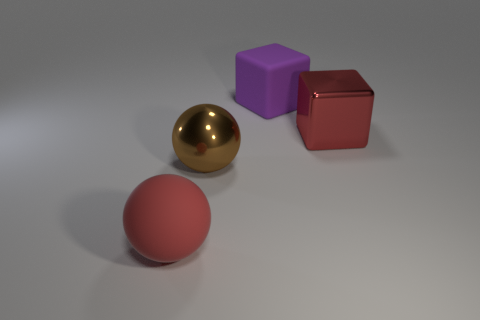Subtract all purple cubes. How many cubes are left? 1 Subtract all red blocks. How many red balls are left? 1 Add 4 big purple matte things. How many objects exist? 8 Subtract all gray spheres. Subtract all gray cylinders. How many spheres are left? 2 Subtract all matte spheres. Subtract all red rubber things. How many objects are left? 2 Add 1 big red shiny objects. How many big red shiny objects are left? 2 Add 1 blue cylinders. How many blue cylinders exist? 1 Subtract 0 green balls. How many objects are left? 4 